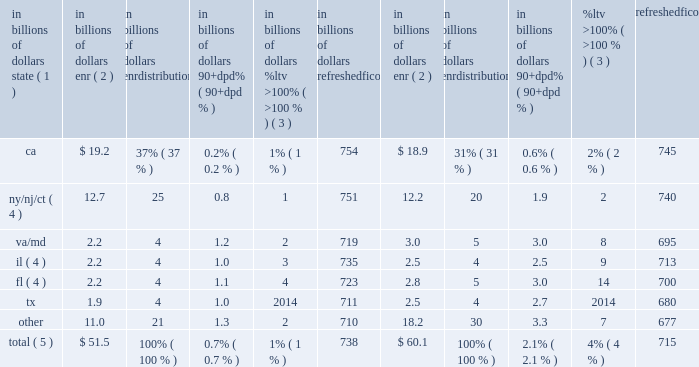During 2015 , continued management actions , primarily the sale or transfer to held-for-sale of approximately $ 1.5 billion of delinquent residential first mortgages , including $ 0.9 billion in the fourth quarter largely associated with the transfer of citifinancial loans to held-for-sale referenced above , were the primary driver of the overall improvement in delinquencies within citi holdings 2019 residential first mortgage portfolio .
Credit performance from quarter to quarter could continue to be impacted by the amount of delinquent loan sales or transfers to held-for-sale , as well as overall trends in hpi and interest rates .
North america residential first mortgages 2014state delinquency trends the tables set forth the six u.s .
States and/or regions with the highest concentration of citi 2019s residential first mortgages. .
Total ( 5 ) $ 51.5 100% ( 100 % ) 0.7% ( 0.7 % ) 1% ( 1 % ) 738 $ 60.1 100% ( 100 % ) 2.1% ( 2.1 % ) 4% ( 4 % ) 715 note : totals may not sum due to rounding .
( 1 ) certain of the states are included as part of a region based on citi 2019s view of similar hpi within the region .
( 2 ) ending net receivables .
Excludes loans in canada and puerto rico , loans guaranteed by u.s .
Government agencies , loans recorded at fair value and loans subject to long term standby commitments ( ltscs ) .
Excludes balances for which fico or ltv data are unavailable .
( 3 ) ltv ratios ( loan balance divided by appraised value ) are calculated at origination and updated by applying market price data .
( 4 ) new york , new jersey , connecticut , florida and illinois are judicial states .
( 5 ) improvement in state trends during 2015 was primarily due to the sale or transfer to held-for-sale of residential first mortgages , including the transfer of citifinancial residential first mortgages to held-for-sale in the fourth quarter of 2015 .
Foreclosures a substantial majority of citi 2019s foreclosure inventory consists of residential first mortgages .
At december 31 , 2015 , citi 2019s foreclosure inventory included approximately $ 0.1 billion , or 0.2% ( 0.2 % ) , of the total residential first mortgage portfolio , compared to $ 0.6 billion , or 0.9% ( 0.9 % ) , at december 31 , 2014 , based on the dollar amount of ending net receivables of loans in foreclosure inventory , excluding loans that are guaranteed by u.s .
Government agencies and loans subject to ltscs .
North america consumer mortgage quarterly credit trends 2014net credit losses and delinquencies 2014home equity citi 2019s home equity loan portfolio consists of both fixed-rate home equity loans and loans extended under home equity lines of credit .
Fixed-rate home equity loans are fully amortizing .
Home equity lines of credit allow for amounts to be drawn for a period of time with the payment of interest only and then , at the end of the draw period , the then-outstanding amount is converted to an amortizing loan ( the interest-only payment feature during the revolving period is standard for this product across the industry ) .
After conversion , the home equity loans typically have a 20-year amortization period .
As of december 31 , 2015 , citi 2019s home equity loan portfolio of $ 22.8 billion consisted of $ 6.3 billion of fixed-rate home equity loans and $ 16.5 billion of loans extended under home equity lines of credit ( revolving helocs ) . .
What percentage of citi's home equity portfolio as of december 31 , 2015 was comprised of loans extended under home equity lines of credit ( revolving helocs ) ? 
Computations: (16.5 / 22.8)
Answer: 0.72368. 